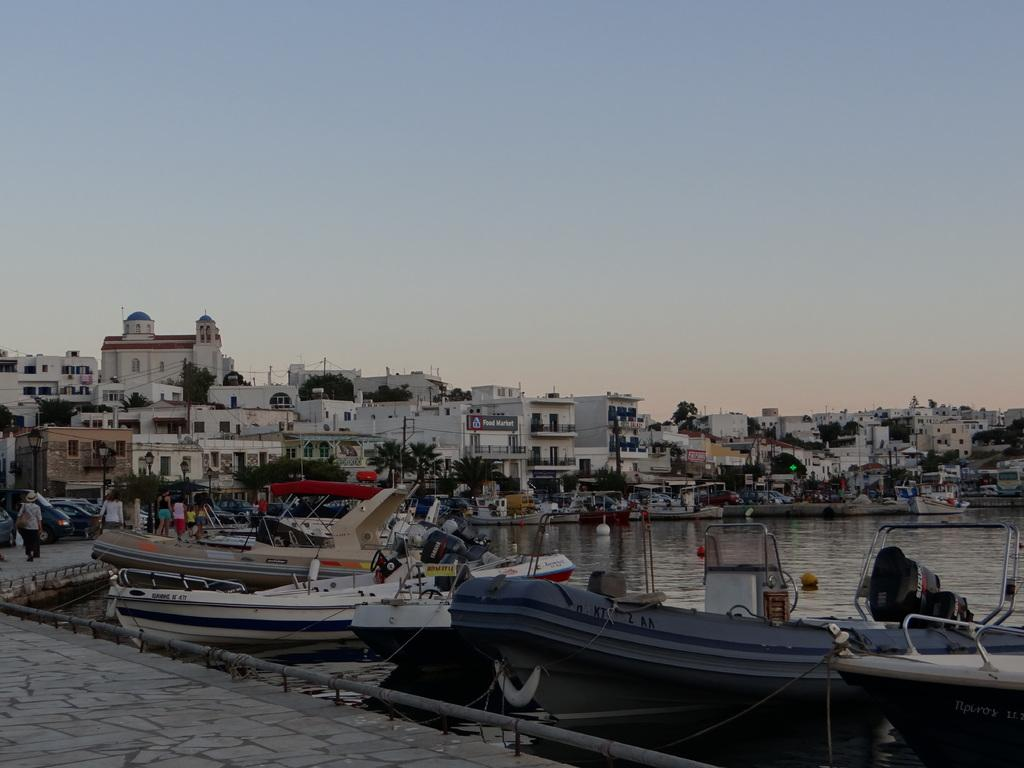What type of structures can be seen in the image? There are many buildings in the image. What mode of transportation is present in the image? There are boats in the image. What are the people in the image doing? There are people walking on the pavement on the left side of the image. What natural feature is visible in the middle of the image? There is water in the middle of the image. What is visible at the top of the image? The sky is visible at the top of the image. What type of snow can be seen on the back of the committee in the image? There is no committee or snow present in the image. What direction are the people walking in the image? The direction in which the people are walking is not specified in the image. 